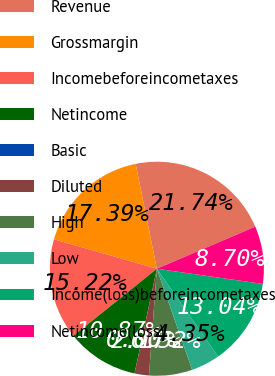Convert chart. <chart><loc_0><loc_0><loc_500><loc_500><pie_chart><fcel>Revenue<fcel>Grossmargin<fcel>Incomebeforeincometaxes<fcel>Netincome<fcel>Basic<fcel>Diluted<fcel>High<fcel>Low<fcel>Income(loss)beforeincometaxes<fcel>Netincome(loss)<nl><fcel>21.74%<fcel>17.39%<fcel>15.22%<fcel>10.87%<fcel>0.0%<fcel>2.17%<fcel>6.52%<fcel>4.35%<fcel>13.04%<fcel>8.7%<nl></chart> 